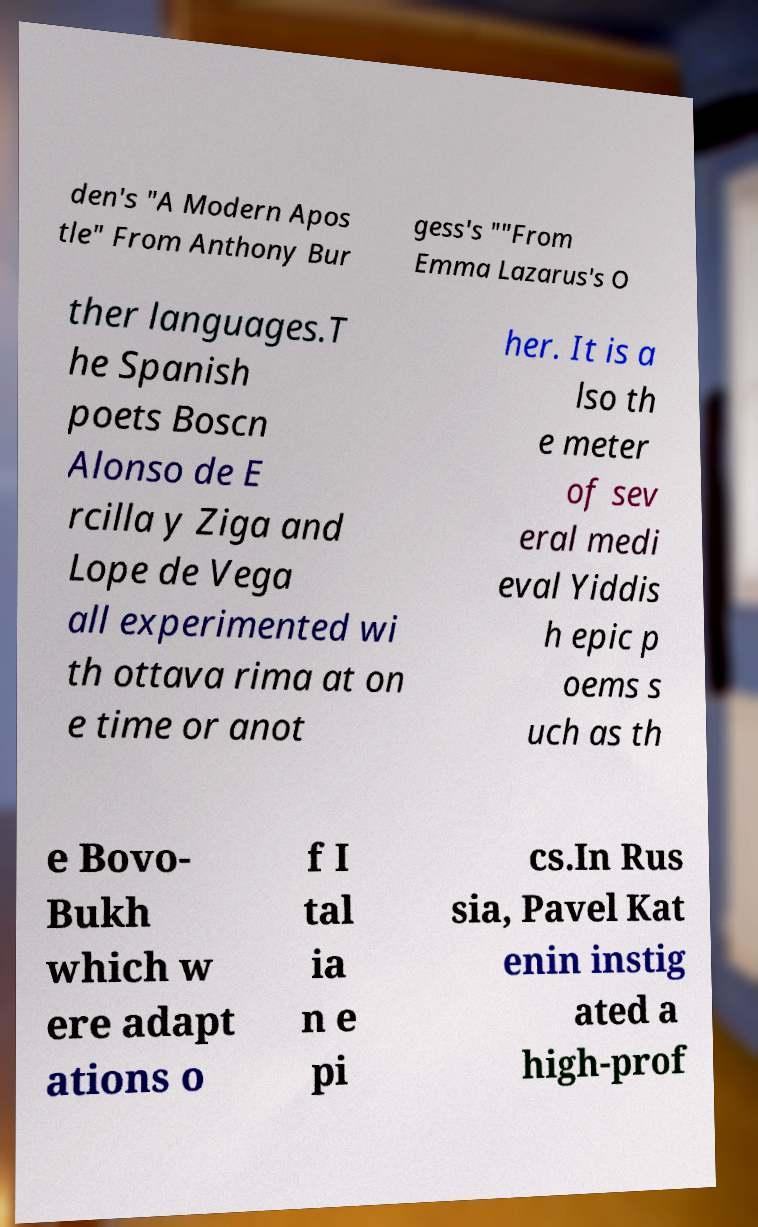Please identify and transcribe the text found in this image. den's "A Modern Apos tle" From Anthony Bur gess's ""From Emma Lazarus's O ther languages.T he Spanish poets Boscn Alonso de E rcilla y Ziga and Lope de Vega all experimented wi th ottava rima at on e time or anot her. It is a lso th e meter of sev eral medi eval Yiddis h epic p oems s uch as th e Bovo- Bukh which w ere adapt ations o f I tal ia n e pi cs.In Rus sia, Pavel Kat enin instig ated a high-prof 